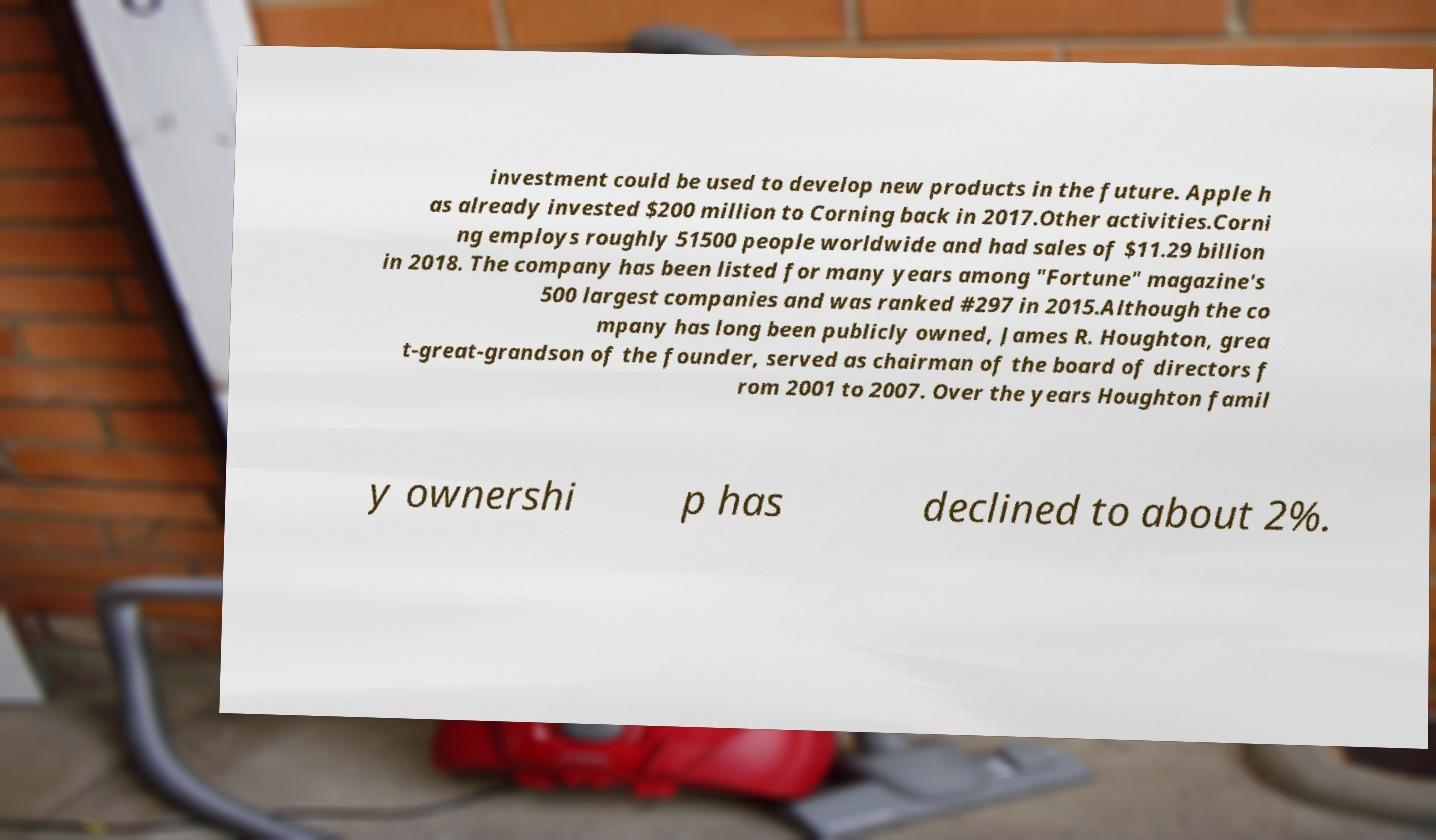I need the written content from this picture converted into text. Can you do that? investment could be used to develop new products in the future. Apple h as already invested $200 million to Corning back in 2017.Other activities.Corni ng employs roughly 51500 people worldwide and had sales of $11.29 billion in 2018. The company has been listed for many years among "Fortune" magazine's 500 largest companies and was ranked #297 in 2015.Although the co mpany has long been publicly owned, James R. Houghton, grea t-great-grandson of the founder, served as chairman of the board of directors f rom 2001 to 2007. Over the years Houghton famil y ownershi p has declined to about 2%. 